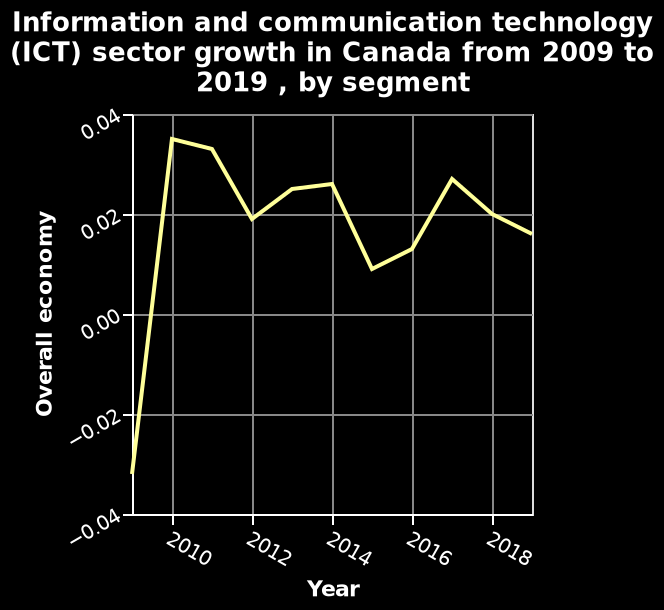<image>
What is the time frame covered by the line plot? The line plot covers the years from 2009 to 2019. What does the y-axis represent?  The y-axis represents the overall economy, using a scale ranging from -0.04 to 0.04. 